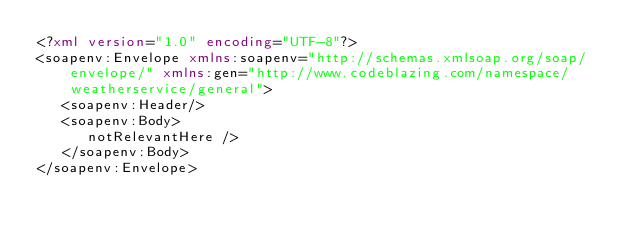Convert code to text. <code><loc_0><loc_0><loc_500><loc_500><_XML_><?xml version="1.0" encoding="UTF-8"?>
<soapenv:Envelope xmlns:soapenv="http://schemas.xmlsoap.org/soap/envelope/" xmlns:gen="http://www.codeblazing.com/namespace/weatherservice/general">
   <soapenv:Header/>
   <soapenv:Body>
      notRelevantHere />
   </soapenv:Body>
</soapenv:Envelope></code> 